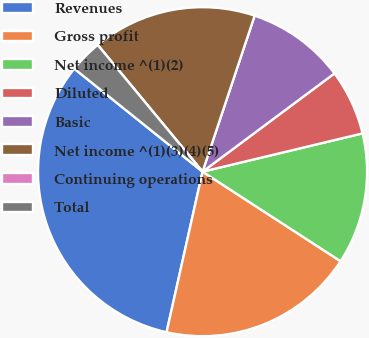Convert chart. <chart><loc_0><loc_0><loc_500><loc_500><pie_chart><fcel>Revenues<fcel>Gross profit<fcel>Net income ^(1)(2)<fcel>Diluted<fcel>Basic<fcel>Net income ^(1)(3)(4)(5)<fcel>Continuing operations<fcel>Total<nl><fcel>32.26%<fcel>19.35%<fcel>12.9%<fcel>6.45%<fcel>9.68%<fcel>16.13%<fcel>0.0%<fcel>3.23%<nl></chart> 